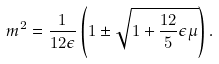<formula> <loc_0><loc_0><loc_500><loc_500>m ^ { 2 } = \frac { 1 } { 1 2 \epsilon } \left ( 1 \pm \sqrt { 1 + \frac { 1 2 } { 5 } \epsilon \mu } \right ) .</formula> 